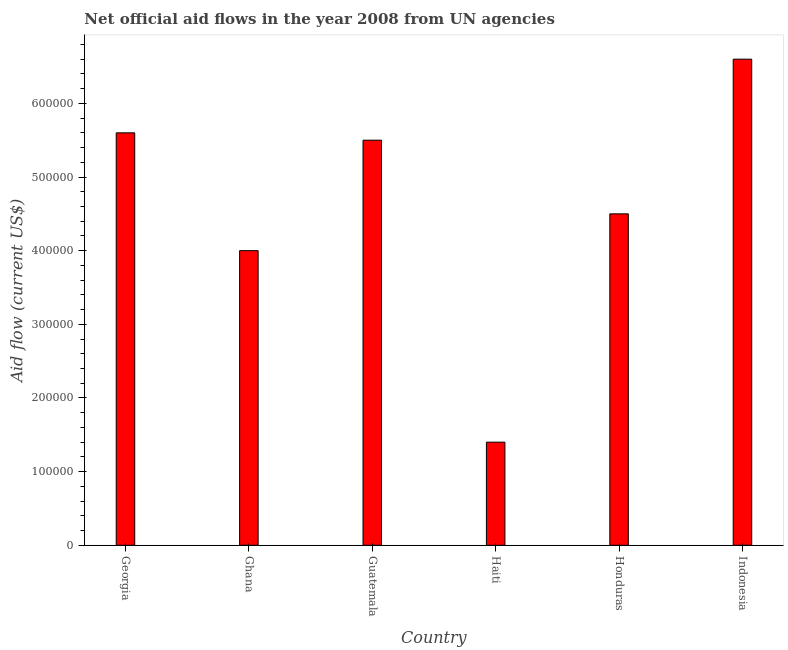Does the graph contain any zero values?
Give a very brief answer. No. Does the graph contain grids?
Provide a short and direct response. No. What is the title of the graph?
Your answer should be compact. Net official aid flows in the year 2008 from UN agencies. What is the label or title of the Y-axis?
Ensure brevity in your answer.  Aid flow (current US$). In which country was the net official flows from un agencies maximum?
Your response must be concise. Indonesia. In which country was the net official flows from un agencies minimum?
Offer a very short reply. Haiti. What is the sum of the net official flows from un agencies?
Your response must be concise. 2.76e+06. What is the difference between the net official flows from un agencies in Haiti and Indonesia?
Keep it short and to the point. -5.20e+05. What is the average net official flows from un agencies per country?
Keep it short and to the point. 4.60e+05. What is the median net official flows from un agencies?
Make the answer very short. 5.00e+05. In how many countries, is the net official flows from un agencies greater than 640000 US$?
Your answer should be compact. 1. What is the ratio of the net official flows from un agencies in Georgia to that in Honduras?
Offer a terse response. 1.24. What is the difference between the highest and the second highest net official flows from un agencies?
Provide a short and direct response. 1.00e+05. What is the difference between the highest and the lowest net official flows from un agencies?
Ensure brevity in your answer.  5.20e+05. Are all the bars in the graph horizontal?
Provide a succinct answer. No. How many countries are there in the graph?
Provide a succinct answer. 6. What is the difference between two consecutive major ticks on the Y-axis?
Provide a succinct answer. 1.00e+05. Are the values on the major ticks of Y-axis written in scientific E-notation?
Offer a terse response. No. What is the Aid flow (current US$) of Georgia?
Offer a terse response. 5.60e+05. What is the Aid flow (current US$) in Indonesia?
Provide a short and direct response. 6.60e+05. What is the difference between the Aid flow (current US$) in Georgia and Ghana?
Your answer should be very brief. 1.60e+05. What is the difference between the Aid flow (current US$) in Georgia and Guatemala?
Your response must be concise. 10000. What is the difference between the Aid flow (current US$) in Georgia and Honduras?
Make the answer very short. 1.10e+05. What is the difference between the Aid flow (current US$) in Georgia and Indonesia?
Make the answer very short. -1.00e+05. What is the difference between the Aid flow (current US$) in Ghana and Honduras?
Your answer should be very brief. -5.00e+04. What is the difference between the Aid flow (current US$) in Ghana and Indonesia?
Ensure brevity in your answer.  -2.60e+05. What is the difference between the Aid flow (current US$) in Guatemala and Haiti?
Provide a short and direct response. 4.10e+05. What is the difference between the Aid flow (current US$) in Guatemala and Honduras?
Offer a terse response. 1.00e+05. What is the difference between the Aid flow (current US$) in Guatemala and Indonesia?
Your answer should be compact. -1.10e+05. What is the difference between the Aid flow (current US$) in Haiti and Honduras?
Make the answer very short. -3.10e+05. What is the difference between the Aid flow (current US$) in Haiti and Indonesia?
Make the answer very short. -5.20e+05. What is the ratio of the Aid flow (current US$) in Georgia to that in Guatemala?
Provide a short and direct response. 1.02. What is the ratio of the Aid flow (current US$) in Georgia to that in Honduras?
Offer a terse response. 1.24. What is the ratio of the Aid flow (current US$) in Georgia to that in Indonesia?
Give a very brief answer. 0.85. What is the ratio of the Aid flow (current US$) in Ghana to that in Guatemala?
Provide a short and direct response. 0.73. What is the ratio of the Aid flow (current US$) in Ghana to that in Haiti?
Your answer should be compact. 2.86. What is the ratio of the Aid flow (current US$) in Ghana to that in Honduras?
Offer a very short reply. 0.89. What is the ratio of the Aid flow (current US$) in Ghana to that in Indonesia?
Provide a succinct answer. 0.61. What is the ratio of the Aid flow (current US$) in Guatemala to that in Haiti?
Ensure brevity in your answer.  3.93. What is the ratio of the Aid flow (current US$) in Guatemala to that in Honduras?
Your answer should be very brief. 1.22. What is the ratio of the Aid flow (current US$) in Guatemala to that in Indonesia?
Your answer should be compact. 0.83. What is the ratio of the Aid flow (current US$) in Haiti to that in Honduras?
Provide a succinct answer. 0.31. What is the ratio of the Aid flow (current US$) in Haiti to that in Indonesia?
Offer a very short reply. 0.21. What is the ratio of the Aid flow (current US$) in Honduras to that in Indonesia?
Provide a succinct answer. 0.68. 